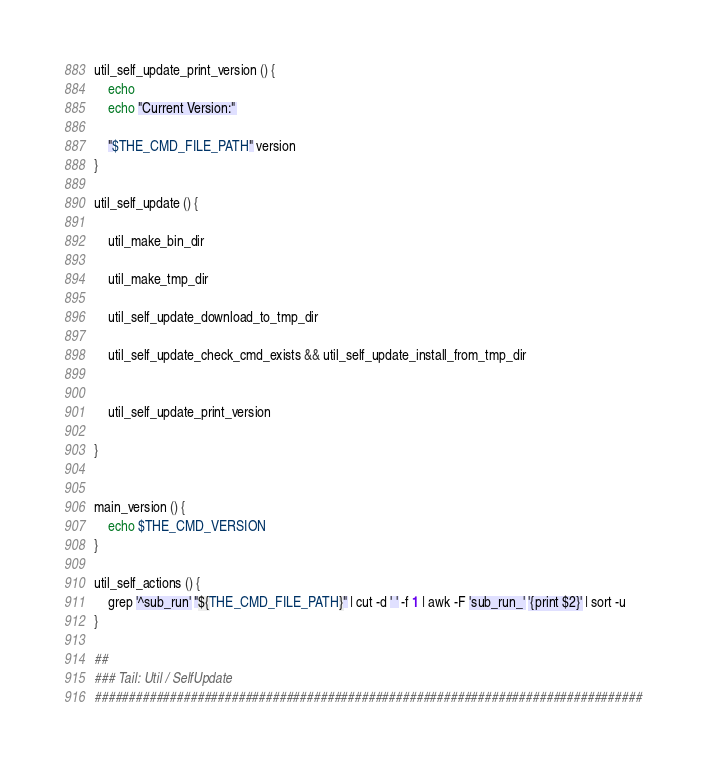<code> <loc_0><loc_0><loc_500><loc_500><_Bash_>
util_self_update_print_version () {
	echo
	echo "Current Version:"

	"$THE_CMD_FILE_PATH" version
}

util_self_update () {

	util_make_bin_dir

	util_make_tmp_dir

	util_self_update_download_to_tmp_dir

	util_self_update_check_cmd_exists && util_self_update_install_from_tmp_dir


	util_self_update_print_version

}


main_version () {
	echo $THE_CMD_VERSION
}

util_self_actions () {
	grep '^sub_run' "${THE_CMD_FILE_PATH}" | cut -d ' ' -f 1 | awk -F 'sub_run_' '{print $2}' | sort -u
}

##
### Tail: Util / SelfUpdate
################################################################################
</code> 